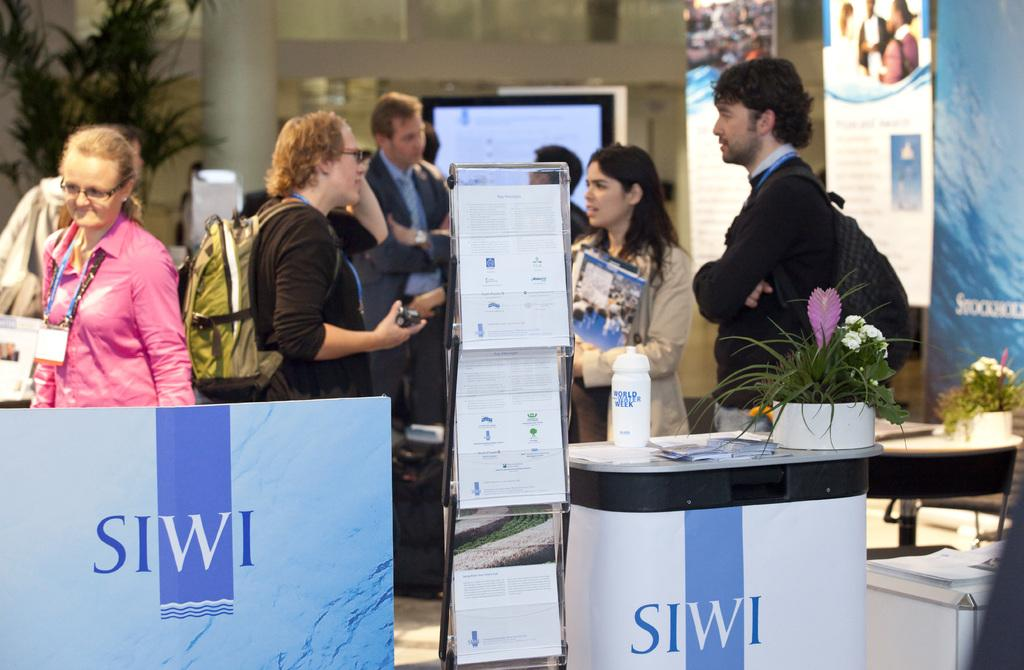<image>
Share a concise interpretation of the image provided. SIWI Company hosting an event where people are coming to talk to hosts. 